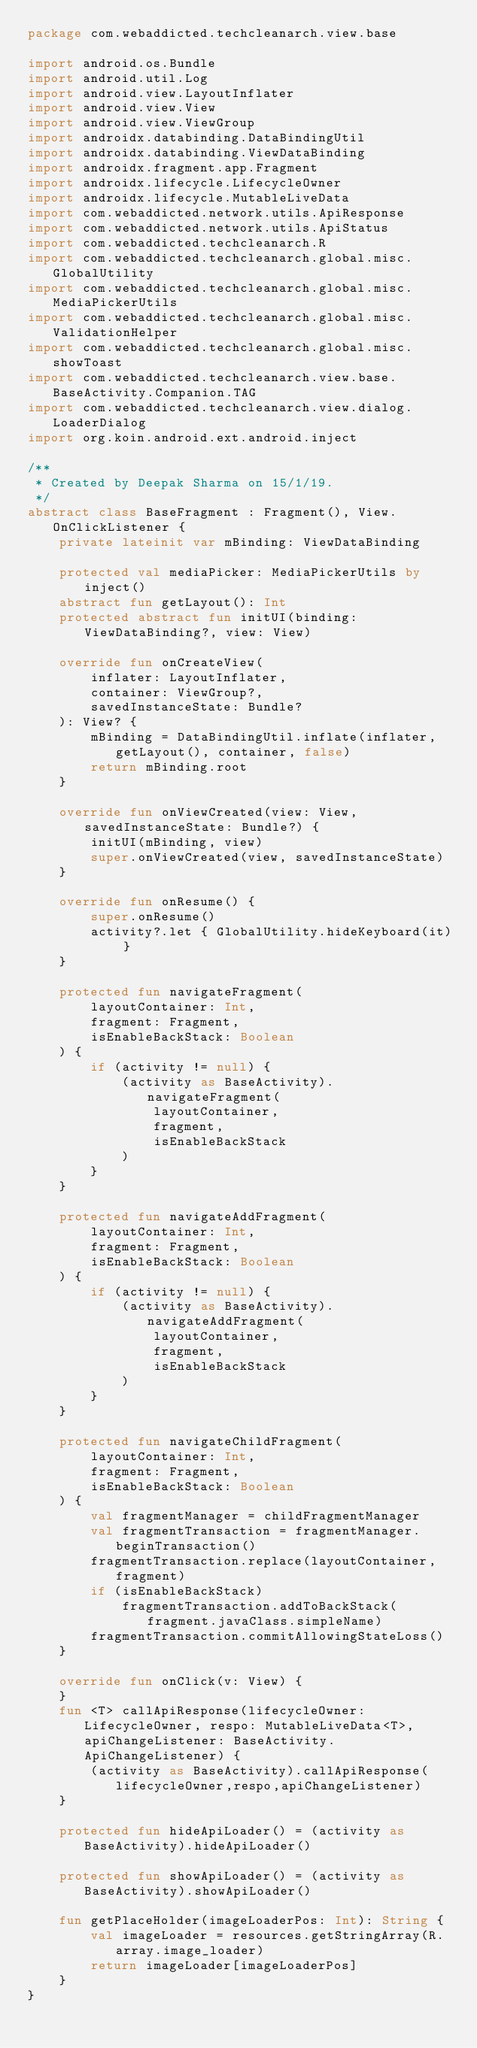<code> <loc_0><loc_0><loc_500><loc_500><_Kotlin_>package com.webaddicted.techcleanarch.view.base

import android.os.Bundle
import android.util.Log
import android.view.LayoutInflater
import android.view.View
import android.view.ViewGroup
import androidx.databinding.DataBindingUtil
import androidx.databinding.ViewDataBinding
import androidx.fragment.app.Fragment
import androidx.lifecycle.LifecycleOwner
import androidx.lifecycle.MutableLiveData
import com.webaddicted.network.utils.ApiResponse
import com.webaddicted.network.utils.ApiStatus
import com.webaddicted.techcleanarch.R
import com.webaddicted.techcleanarch.global.misc.GlobalUtility
import com.webaddicted.techcleanarch.global.misc.MediaPickerUtils
import com.webaddicted.techcleanarch.global.misc.ValidationHelper
import com.webaddicted.techcleanarch.global.misc.showToast
import com.webaddicted.techcleanarch.view.base.BaseActivity.Companion.TAG
import com.webaddicted.techcleanarch.view.dialog.LoaderDialog
import org.koin.android.ext.android.inject

/**
 * Created by Deepak Sharma on 15/1/19.
 */
abstract class BaseFragment : Fragment(), View.OnClickListener {
    private lateinit var mBinding: ViewDataBinding

    protected val mediaPicker: MediaPickerUtils by inject()
    abstract fun getLayout(): Int
    protected abstract fun initUI(binding: ViewDataBinding?, view: View)

    override fun onCreateView(
        inflater: LayoutInflater,
        container: ViewGroup?,
        savedInstanceState: Bundle?
    ): View? {
        mBinding = DataBindingUtil.inflate(inflater, getLayout(), container, false)
        return mBinding.root
    }

    override fun onViewCreated(view: View, savedInstanceState: Bundle?) {
        initUI(mBinding, view)
        super.onViewCreated(view, savedInstanceState)
    }

    override fun onResume() {
        super.onResume()
        activity?.let { GlobalUtility.hideKeyboard(it) }
    }

    protected fun navigateFragment(
        layoutContainer: Int,
        fragment: Fragment,
        isEnableBackStack: Boolean
    ) {
        if (activity != null) {
            (activity as BaseActivity).navigateFragment(
                layoutContainer,
                fragment,
                isEnableBackStack
            )
        }
    }

    protected fun navigateAddFragment(
        layoutContainer: Int,
        fragment: Fragment,
        isEnableBackStack: Boolean
    ) {
        if (activity != null) {
            (activity as BaseActivity).navigateAddFragment(
                layoutContainer,
                fragment,
                isEnableBackStack
            )
        }
    }

    protected fun navigateChildFragment(
        layoutContainer: Int,
        fragment: Fragment,
        isEnableBackStack: Boolean
    ) {
        val fragmentManager = childFragmentManager
        val fragmentTransaction = fragmentManager.beginTransaction()
        fragmentTransaction.replace(layoutContainer, fragment)
        if (isEnableBackStack)
            fragmentTransaction.addToBackStack(fragment.javaClass.simpleName)
        fragmentTransaction.commitAllowingStateLoss()
    }

    override fun onClick(v: View) {
    }
    fun <T> callApiResponse(lifecycleOwner: LifecycleOwner, respo: MutableLiveData<T>, apiChangeListener: BaseActivity.ApiChangeListener) {
        (activity as BaseActivity).callApiResponse(lifecycleOwner,respo,apiChangeListener)
    }

    protected fun hideApiLoader() = (activity as BaseActivity).hideApiLoader()

    protected fun showApiLoader() = (activity as BaseActivity).showApiLoader()

    fun getPlaceHolder(imageLoaderPos: Int): String {
        val imageLoader = resources.getStringArray(R.array.image_loader)
        return imageLoader[imageLoaderPos]
    }
}
</code> 